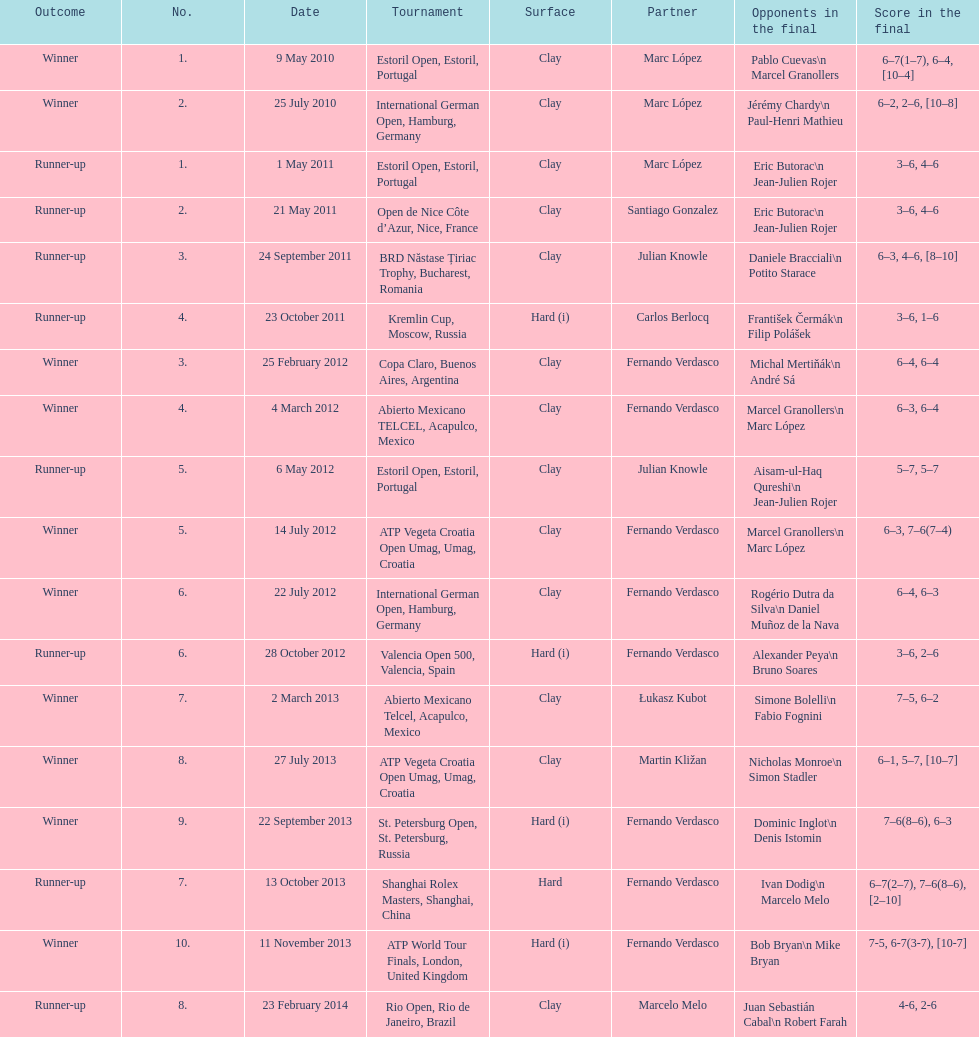What event was held subsequent to the kremlin cup? Copa Claro, Buenos Aires, Argentina. Parse the full table. {'header': ['Outcome', 'No.', 'Date', 'Tournament', 'Surface', 'Partner', 'Opponents in the final', 'Score in the final'], 'rows': [['Winner', '1.', '9 May 2010', 'Estoril Open, Estoril, Portugal', 'Clay', 'Marc López', 'Pablo Cuevas\\n Marcel Granollers', '6–7(1–7), 6–4, [10–4]'], ['Winner', '2.', '25 July 2010', 'International German Open, Hamburg, Germany', 'Clay', 'Marc López', 'Jérémy Chardy\\n Paul-Henri Mathieu', '6–2, 2–6, [10–8]'], ['Runner-up', '1.', '1 May 2011', 'Estoril Open, Estoril, Portugal', 'Clay', 'Marc López', 'Eric Butorac\\n Jean-Julien Rojer', '3–6, 4–6'], ['Runner-up', '2.', '21 May 2011', 'Open de Nice Côte d’Azur, Nice, France', 'Clay', 'Santiago Gonzalez', 'Eric Butorac\\n Jean-Julien Rojer', '3–6, 4–6'], ['Runner-up', '3.', '24 September 2011', 'BRD Năstase Țiriac Trophy, Bucharest, Romania', 'Clay', 'Julian Knowle', 'Daniele Bracciali\\n Potito Starace', '6–3, 4–6, [8–10]'], ['Runner-up', '4.', '23 October 2011', 'Kremlin Cup, Moscow, Russia', 'Hard (i)', 'Carlos Berlocq', 'František Čermák\\n Filip Polášek', '3–6, 1–6'], ['Winner', '3.', '25 February 2012', 'Copa Claro, Buenos Aires, Argentina', 'Clay', 'Fernando Verdasco', 'Michal Mertiňák\\n André Sá', '6–4, 6–4'], ['Winner', '4.', '4 March 2012', 'Abierto Mexicano TELCEL, Acapulco, Mexico', 'Clay', 'Fernando Verdasco', 'Marcel Granollers\\n Marc López', '6–3, 6–4'], ['Runner-up', '5.', '6 May 2012', 'Estoril Open, Estoril, Portugal', 'Clay', 'Julian Knowle', 'Aisam-ul-Haq Qureshi\\n Jean-Julien Rojer', '5–7, 5–7'], ['Winner', '5.', '14 July 2012', 'ATP Vegeta Croatia Open Umag, Umag, Croatia', 'Clay', 'Fernando Verdasco', 'Marcel Granollers\\n Marc López', '6–3, 7–6(7–4)'], ['Winner', '6.', '22 July 2012', 'International German Open, Hamburg, Germany', 'Clay', 'Fernando Verdasco', 'Rogério Dutra da Silva\\n Daniel Muñoz de la Nava', '6–4, 6–3'], ['Runner-up', '6.', '28 October 2012', 'Valencia Open 500, Valencia, Spain', 'Hard (i)', 'Fernando Verdasco', 'Alexander Peya\\n Bruno Soares', '3–6, 2–6'], ['Winner', '7.', '2 March 2013', 'Abierto Mexicano Telcel, Acapulco, Mexico', 'Clay', 'Łukasz Kubot', 'Simone Bolelli\\n Fabio Fognini', '7–5, 6–2'], ['Winner', '8.', '27 July 2013', 'ATP Vegeta Croatia Open Umag, Umag, Croatia', 'Clay', 'Martin Kližan', 'Nicholas Monroe\\n Simon Stadler', '6–1, 5–7, [10–7]'], ['Winner', '9.', '22 September 2013', 'St. Petersburg Open, St. Petersburg, Russia', 'Hard (i)', 'Fernando Verdasco', 'Dominic Inglot\\n Denis Istomin', '7–6(8–6), 6–3'], ['Runner-up', '7.', '13 October 2013', 'Shanghai Rolex Masters, Shanghai, China', 'Hard', 'Fernando Verdasco', 'Ivan Dodig\\n Marcelo Melo', '6–7(2–7), 7–6(8–6), [2–10]'], ['Winner', '10.', '11 November 2013', 'ATP World Tour Finals, London, United Kingdom', 'Hard (i)', 'Fernando Verdasco', 'Bob Bryan\\n Mike Bryan', '7-5, 6-7(3-7), [10-7]'], ['Runner-up', '8.', '23 February 2014', 'Rio Open, Rio de Janeiro, Brazil', 'Clay', 'Marcelo Melo', 'Juan Sebastián Cabal\\n Robert Farah', '4-6, 2-6']]} 